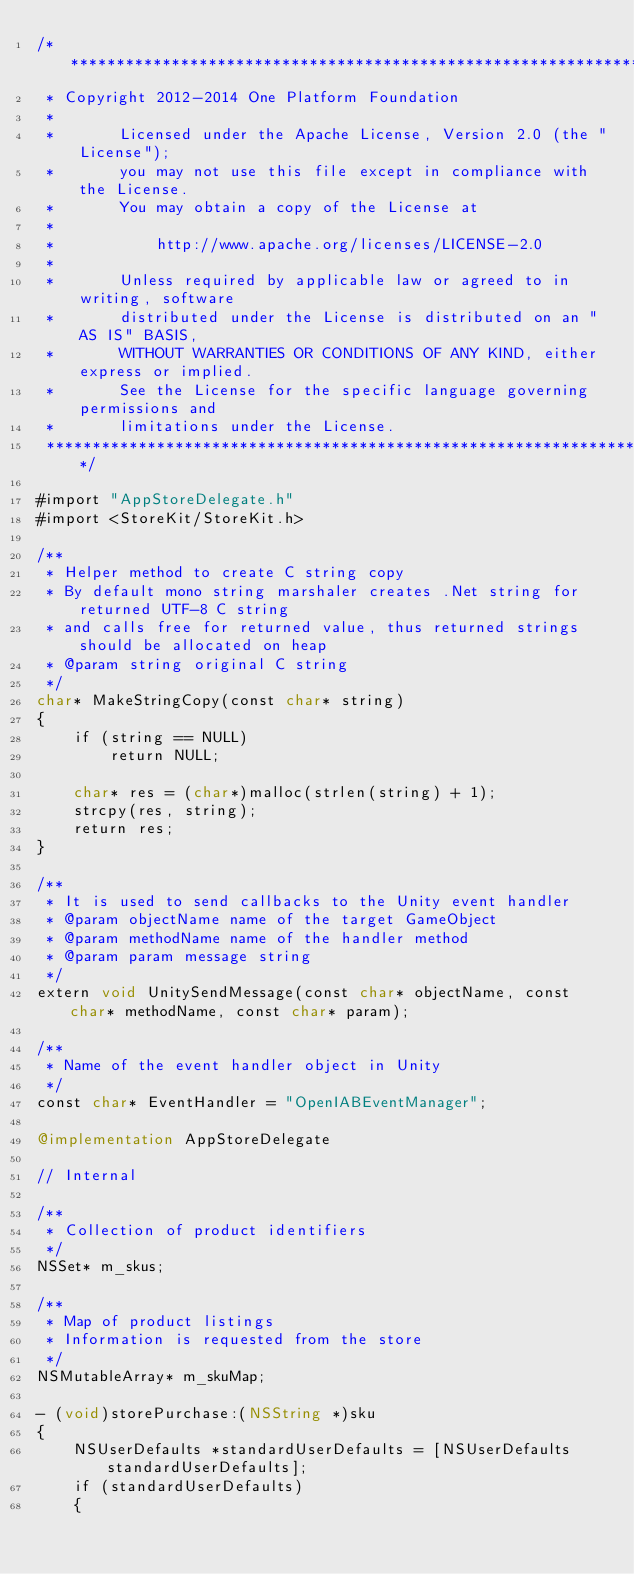Convert code to text. <code><loc_0><loc_0><loc_500><loc_500><_ObjectiveC_>/*******************************************************************************
 * Copyright 2012-2014 One Platform Foundation
 *
 *       Licensed under the Apache License, Version 2.0 (the "License");
 *       you may not use this file except in compliance with the License.
 *       You may obtain a copy of the License at
 *
 *           http://www.apache.org/licenses/LICENSE-2.0
 *
 *       Unless required by applicable law or agreed to in writing, software
 *       distributed under the License is distributed on an "AS IS" BASIS,
 *       WITHOUT WARRANTIES OR CONDITIONS OF ANY KIND, either express or implied.
 *       See the License for the specific language governing permissions and
 *       limitations under the License.
 ******************************************************************************/

#import "AppStoreDelegate.h"
#import <StoreKit/StoreKit.h>

/**
 * Helper method to create C string copy
 * By default mono string marshaler creates .Net string for returned UTF-8 C string
 * and calls free for returned value, thus returned strings should be allocated on heap
 * @param string original C string
 */
char* MakeStringCopy(const char* string)
{
    if (string == NULL)
        return NULL;
    
    char* res = (char*)malloc(strlen(string) + 1);
    strcpy(res, string);
    return res;
}

/**
 * It is used to send callbacks to the Unity event handler
 * @param objectName name of the target GameObject
 * @param methodName name of the handler method
 * @param param message string
 */
extern void UnitySendMessage(const char* objectName, const char* methodName, const char* param);

/**
 * Name of the event handler object in Unity
 */
const char* EventHandler = "OpenIABEventManager";

@implementation AppStoreDelegate

// Internal

/**
 * Collection of product identifiers
 */
NSSet* m_skus;

/**
 * Map of product listings
 * Information is requested from the store
 */
NSMutableArray* m_skuMap;

- (void)storePurchase:(NSString *)sku
{
    NSUserDefaults *standardUserDefaults = [NSUserDefaults standardUserDefaults];
    if (standardUserDefaults)
    {</code> 